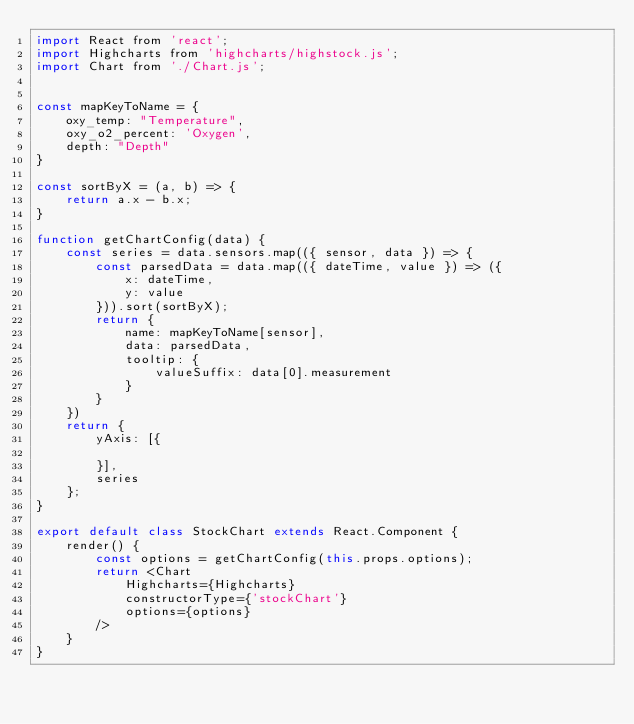<code> <loc_0><loc_0><loc_500><loc_500><_JavaScript_>import React from 'react';
import Highcharts from 'highcharts/highstock.js';
import Chart from './Chart.js';


const mapKeyToName = {
    oxy_temp: "Temperature",
    oxy_o2_percent: 'Oxygen',
    depth: "Depth"
}

const sortByX = (a, b) => {
    return a.x - b.x;
}

function getChartConfig(data) {
    const series = data.sensors.map(({ sensor, data }) => {
        const parsedData = data.map(({ dateTime, value }) => ({
            x: dateTime,
            y: value
        })).sort(sortByX);
        return {
            name: mapKeyToName[sensor],
            data: parsedData,
            tooltip: {
                valueSuffix: data[0].measurement
            }
        }
    })
    return {
        yAxis: [{

        }],
        series
    };
}

export default class StockChart extends React.Component {
    render() {
        const options = getChartConfig(this.props.options);
        return <Chart 
            Highcharts={Highcharts}
            constructorType={'stockChart'}
            options={options}
        />
    }
}</code> 